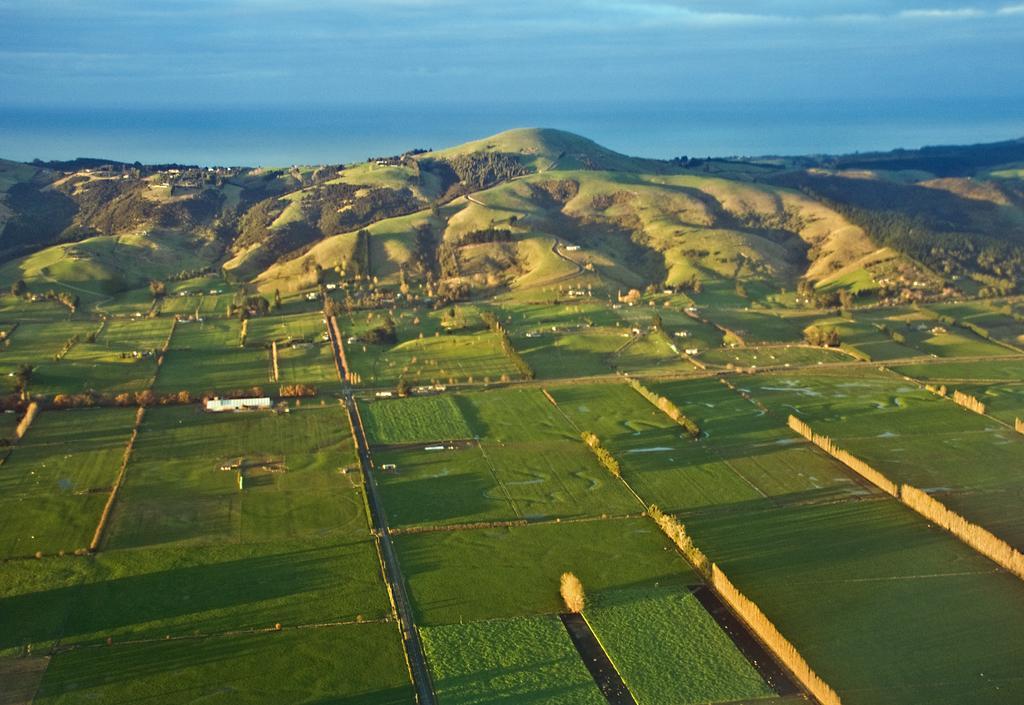How would you summarize this image in a sentence or two? In this image there is grass on the ground and there are trees and mountains and the sky is cloudy. 